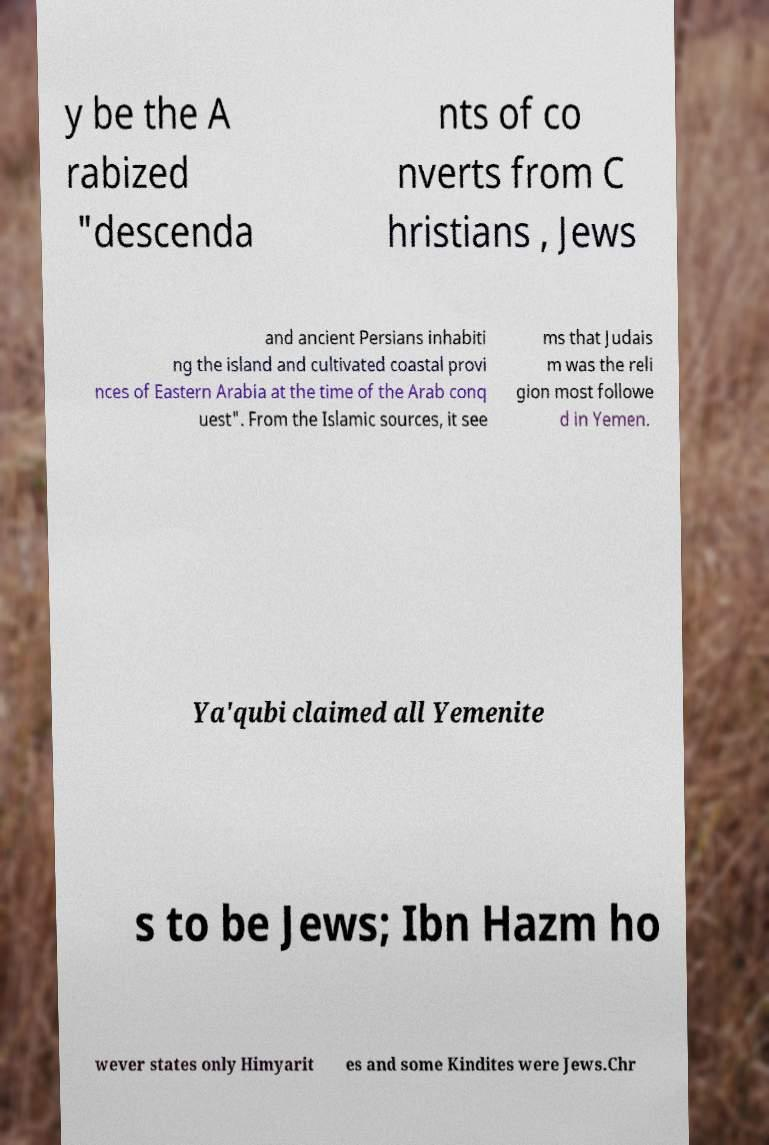There's text embedded in this image that I need extracted. Can you transcribe it verbatim? y be the A rabized "descenda nts of co nverts from C hristians , Jews and ancient Persians inhabiti ng the island and cultivated coastal provi nces of Eastern Arabia at the time of the Arab conq uest". From the Islamic sources, it see ms that Judais m was the reli gion most followe d in Yemen. Ya'qubi claimed all Yemenite s to be Jews; Ibn Hazm ho wever states only Himyarit es and some Kindites were Jews.Chr 